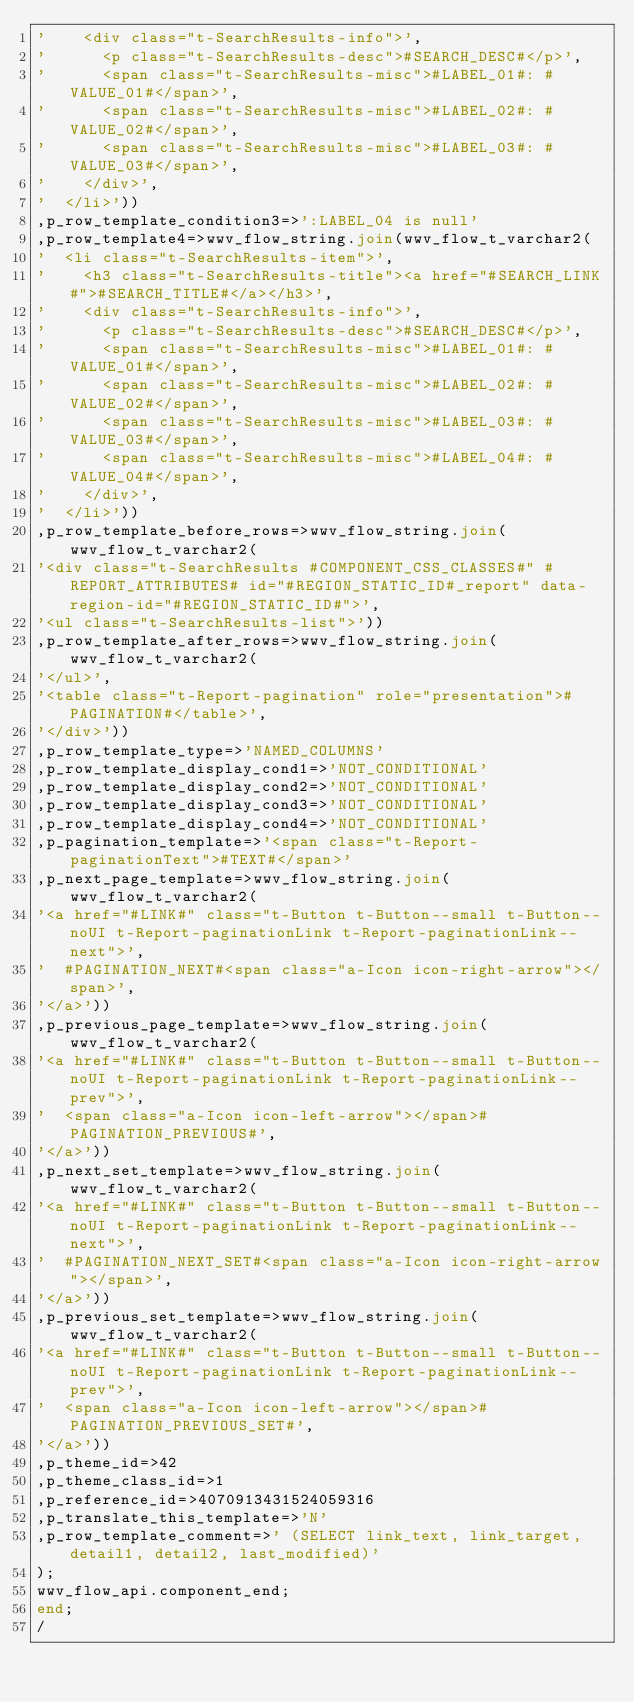<code> <loc_0><loc_0><loc_500><loc_500><_SQL_>'    <div class="t-SearchResults-info">',
'      <p class="t-SearchResults-desc">#SEARCH_DESC#</p>',
'      <span class="t-SearchResults-misc">#LABEL_01#: #VALUE_01#</span>',
'      <span class="t-SearchResults-misc">#LABEL_02#: #VALUE_02#</span>',
'      <span class="t-SearchResults-misc">#LABEL_03#: #VALUE_03#</span>',
'    </div>',
'  </li>'))
,p_row_template_condition3=>':LABEL_04 is null'
,p_row_template4=>wwv_flow_string.join(wwv_flow_t_varchar2(
'  <li class="t-SearchResults-item">',
'    <h3 class="t-SearchResults-title"><a href="#SEARCH_LINK#">#SEARCH_TITLE#</a></h3>',
'    <div class="t-SearchResults-info">',
'      <p class="t-SearchResults-desc">#SEARCH_DESC#</p>',
'      <span class="t-SearchResults-misc">#LABEL_01#: #VALUE_01#</span>',
'      <span class="t-SearchResults-misc">#LABEL_02#: #VALUE_02#</span>',
'      <span class="t-SearchResults-misc">#LABEL_03#: #VALUE_03#</span>',
'      <span class="t-SearchResults-misc">#LABEL_04#: #VALUE_04#</span>',
'    </div>',
'  </li>'))
,p_row_template_before_rows=>wwv_flow_string.join(wwv_flow_t_varchar2(
'<div class="t-SearchResults #COMPONENT_CSS_CLASSES#" #REPORT_ATTRIBUTES# id="#REGION_STATIC_ID#_report" data-region-id="#REGION_STATIC_ID#">',
'<ul class="t-SearchResults-list">'))
,p_row_template_after_rows=>wwv_flow_string.join(wwv_flow_t_varchar2(
'</ul>',
'<table class="t-Report-pagination" role="presentation">#PAGINATION#</table>',
'</div>'))
,p_row_template_type=>'NAMED_COLUMNS'
,p_row_template_display_cond1=>'NOT_CONDITIONAL'
,p_row_template_display_cond2=>'NOT_CONDITIONAL'
,p_row_template_display_cond3=>'NOT_CONDITIONAL'
,p_row_template_display_cond4=>'NOT_CONDITIONAL'
,p_pagination_template=>'<span class="t-Report-paginationText">#TEXT#</span>'
,p_next_page_template=>wwv_flow_string.join(wwv_flow_t_varchar2(
'<a href="#LINK#" class="t-Button t-Button--small t-Button--noUI t-Report-paginationLink t-Report-paginationLink--next">',
'  #PAGINATION_NEXT#<span class="a-Icon icon-right-arrow"></span>',
'</a>'))
,p_previous_page_template=>wwv_flow_string.join(wwv_flow_t_varchar2(
'<a href="#LINK#" class="t-Button t-Button--small t-Button--noUI t-Report-paginationLink t-Report-paginationLink--prev">',
'  <span class="a-Icon icon-left-arrow"></span>#PAGINATION_PREVIOUS#',
'</a>'))
,p_next_set_template=>wwv_flow_string.join(wwv_flow_t_varchar2(
'<a href="#LINK#" class="t-Button t-Button--small t-Button--noUI t-Report-paginationLink t-Report-paginationLink--next">',
'  #PAGINATION_NEXT_SET#<span class="a-Icon icon-right-arrow"></span>',
'</a>'))
,p_previous_set_template=>wwv_flow_string.join(wwv_flow_t_varchar2(
'<a href="#LINK#" class="t-Button t-Button--small t-Button--noUI t-Report-paginationLink t-Report-paginationLink--prev">',
'  <span class="a-Icon icon-left-arrow"></span>#PAGINATION_PREVIOUS_SET#',
'</a>'))
,p_theme_id=>42
,p_theme_class_id=>1
,p_reference_id=>4070913431524059316
,p_translate_this_template=>'N'
,p_row_template_comment=>' (SELECT link_text, link_target, detail1, detail2, last_modified)'
);
wwv_flow_api.component_end;
end;
/
</code> 